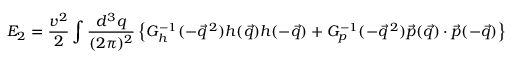<formula> <loc_0><loc_0><loc_500><loc_500>E _ { 2 } = \frac { v ^ { 2 } } { 2 } \int \frac { d ^ { 3 } q } { ( 2 \pi ) ^ { 2 } } \left \{ G _ { h } ^ { - 1 } ( - \vec { q } \, ^ { 2 } ) h ( \vec { q } ) h ( - \vec { q } ) + G _ { p } ^ { - 1 } ( - \vec { q } \, ^ { 2 } ) \vec { p } ( \vec { q } ) \cdot \vec { p } ( - \vec { q } ) \right \}</formula> 